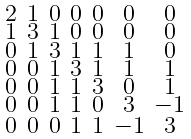<formula> <loc_0><loc_0><loc_500><loc_500>\begin{smallmatrix} 2 & 1 & 0 & 0 & 0 & 0 & 0 \\ 1 & 3 & 1 & 0 & 0 & 0 & 0 \\ 0 & 1 & 3 & 1 & 1 & 1 & 0 \\ 0 & 0 & 1 & 3 & 1 & 1 & 1 \\ 0 & 0 & 1 & 1 & 3 & 0 & 1 \\ 0 & 0 & 1 & 1 & 0 & 3 & - 1 \\ 0 & 0 & 0 & 1 & 1 & - 1 & 3 \end{smallmatrix}</formula> 